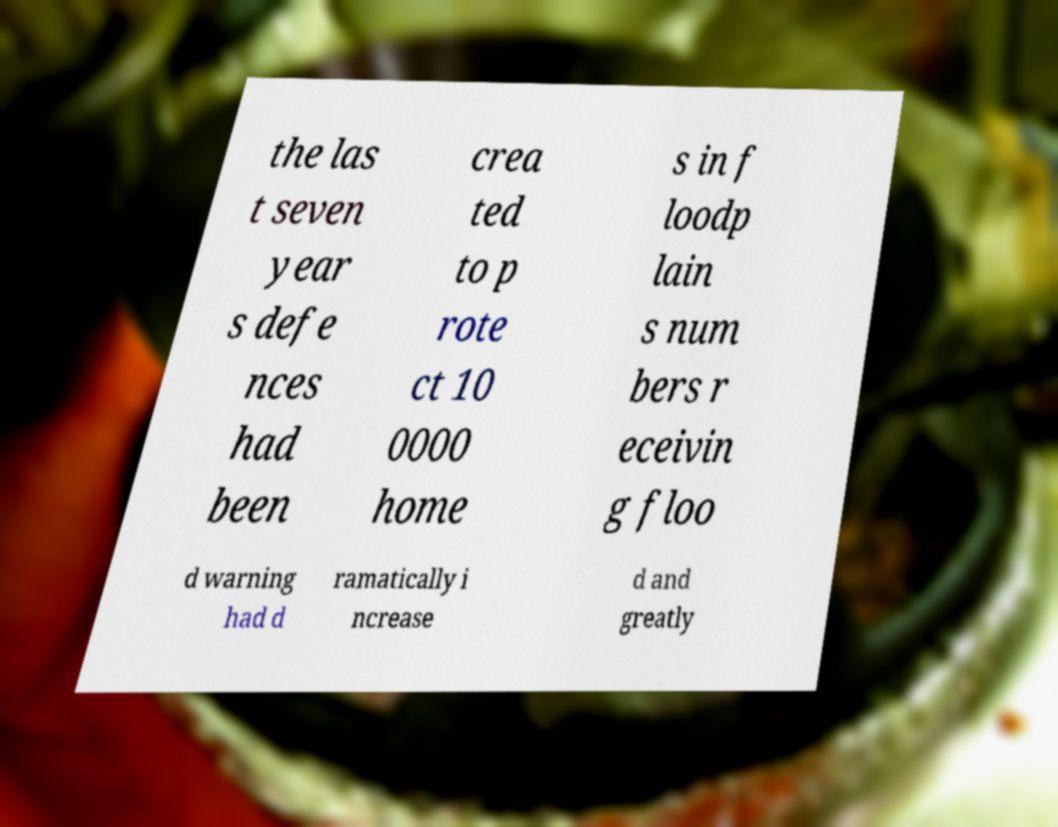What messages or text are displayed in this image? I need them in a readable, typed format. the las t seven year s defe nces had been crea ted to p rote ct 10 0000 home s in f loodp lain s num bers r eceivin g floo d warning had d ramatically i ncrease d and greatly 